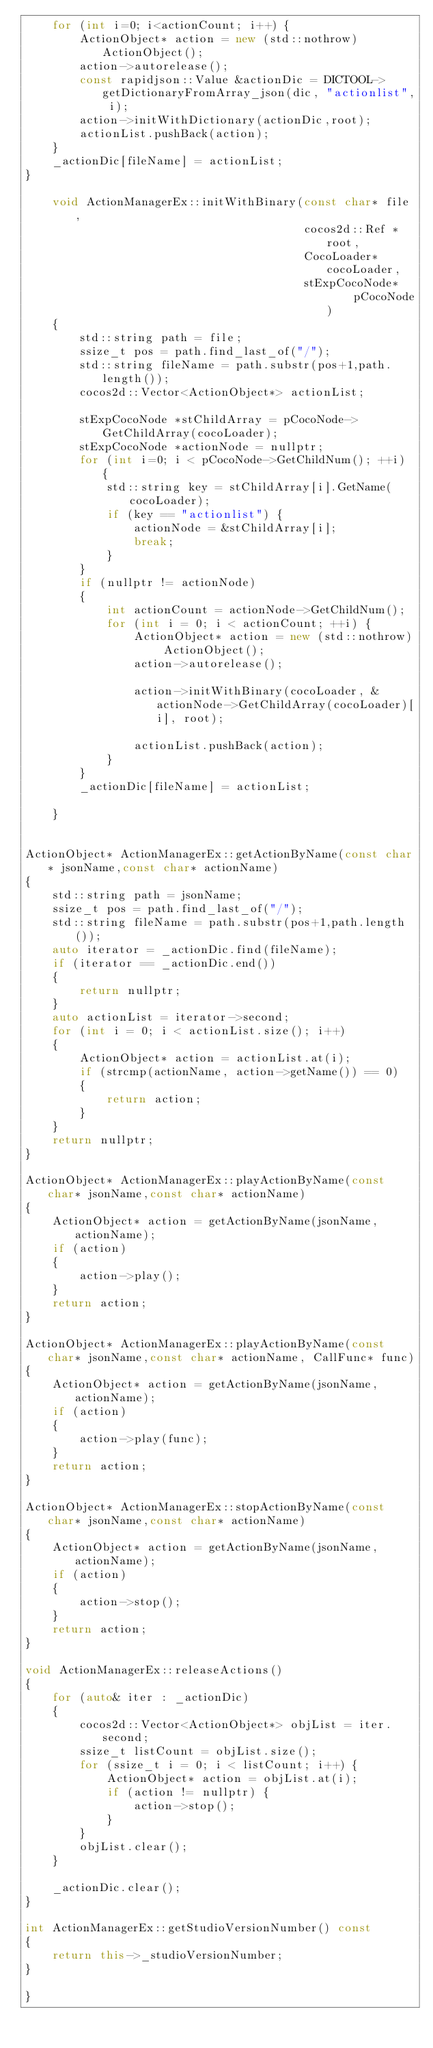Convert code to text. <code><loc_0><loc_0><loc_500><loc_500><_C++_>    for (int i=0; i<actionCount; i++) {
        ActionObject* action = new (std::nothrow) ActionObject();
        action->autorelease();
        const rapidjson::Value &actionDic = DICTOOL->getDictionaryFromArray_json(dic, "actionlist", i);
        action->initWithDictionary(actionDic,root);
        actionList.pushBack(action);
    }
    _actionDic[fileName] = actionList;
}
    
    void ActionManagerEx::initWithBinary(const char* file,
                                         cocos2d::Ref *root,
                                         CocoLoader* cocoLoader,
                                         stExpCocoNode*     pCocoNode)
    {
        std::string path = file;
        ssize_t pos = path.find_last_of("/");
        std::string fileName = path.substr(pos+1,path.length());
        cocos2d::Vector<ActionObject*> actionList;
        
        stExpCocoNode *stChildArray = pCocoNode->GetChildArray(cocoLoader);
        stExpCocoNode *actionNode = nullptr;
        for (int i=0; i < pCocoNode->GetChildNum(); ++i) {
            std::string key = stChildArray[i].GetName(cocoLoader);
            if (key == "actionlist") {
                actionNode = &stChildArray[i];
                break;
            }
        }
        if (nullptr != actionNode)
        {
            int actionCount = actionNode->GetChildNum();
            for (int i = 0; i < actionCount; ++i) {
                ActionObject* action = new (std::nothrow) ActionObject();
                action->autorelease();
                
                action->initWithBinary(cocoLoader, &actionNode->GetChildArray(cocoLoader)[i], root);
                
                actionList.pushBack(action);
            }
        }
        _actionDic[fileName] = actionList;
        
    }


ActionObject* ActionManagerEx::getActionByName(const char* jsonName,const char* actionName)
{
    std::string path = jsonName;
    ssize_t pos = path.find_last_of("/");
    std::string fileName = path.substr(pos+1,path.length());
    auto iterator = _actionDic.find(fileName);
    if (iterator == _actionDic.end())
    {
        return nullptr;
    }
    auto actionList = iterator->second;
    for (int i = 0; i < actionList.size(); i++)
    {
        ActionObject* action = actionList.at(i);
        if (strcmp(actionName, action->getName()) == 0)
        {
            return action;
        }
    }
    return nullptr;
}

ActionObject* ActionManagerEx::playActionByName(const char* jsonName,const char* actionName)
{
    ActionObject* action = getActionByName(jsonName,actionName);
    if (action)
    {
        action->play();
    }
    return action;
}

ActionObject* ActionManagerEx::playActionByName(const char* jsonName,const char* actionName, CallFunc* func)
{
    ActionObject* action = getActionByName(jsonName,actionName);
    if (action)
    {
        action->play(func);
    }
    return action;
}

ActionObject* ActionManagerEx::stopActionByName(const char* jsonName,const char* actionName)
{
    ActionObject* action = getActionByName(jsonName,actionName);
    if (action)
    {
        action->stop();
    }
    return action;
}
    
void ActionManagerEx::releaseActions()
{
    for (auto& iter : _actionDic)
    {
        cocos2d::Vector<ActionObject*> objList = iter.second;
        ssize_t listCount = objList.size();
        for (ssize_t i = 0; i < listCount; i++) {
            ActionObject* action = objList.at(i);
            if (action != nullptr) {
                action->stop();
            }
        }
        objList.clear();
    }
    
    _actionDic.clear();
}

int ActionManagerEx::getStudioVersionNumber() const
{
    return this->_studioVersionNumber;
}

}
</code> 